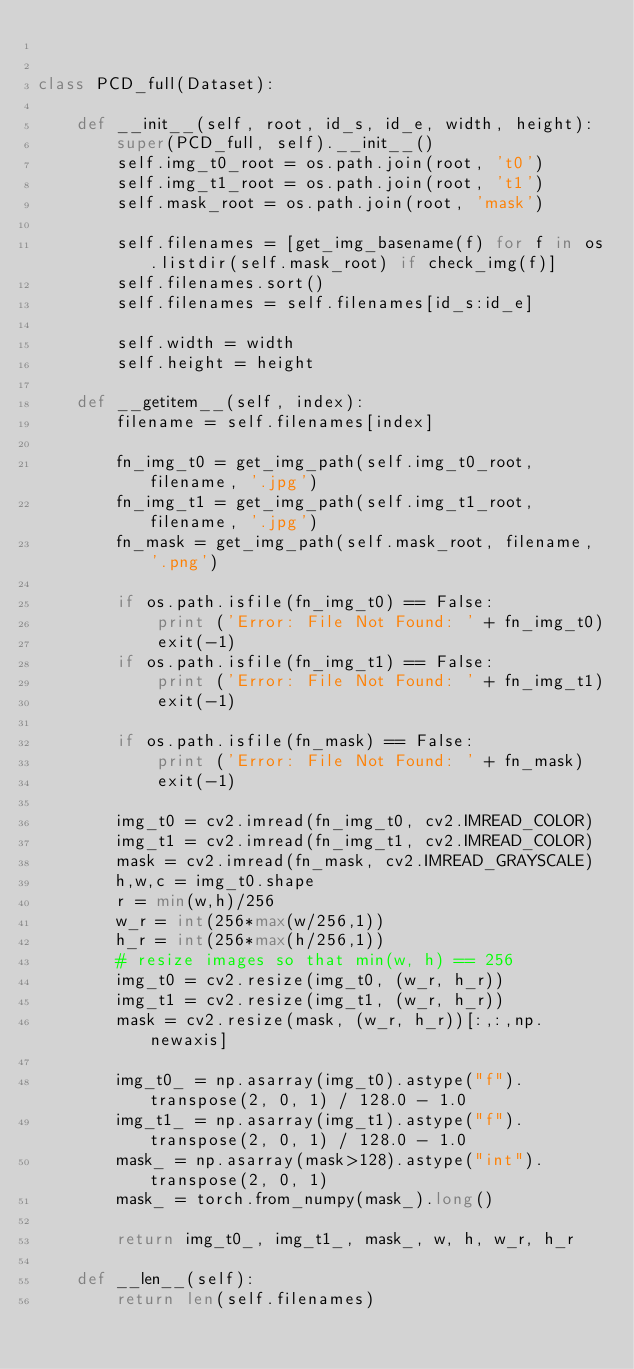Convert code to text. <code><loc_0><loc_0><loc_500><loc_500><_Python_>

class PCD_full(Dataset):

    def __init__(self, root, id_s, id_e, width, height):
        super(PCD_full, self).__init__()
        self.img_t0_root = os.path.join(root, 't0')
        self.img_t1_root = os.path.join(root, 't1')
        self.mask_root = os.path.join(root, 'mask')

        self.filenames = [get_img_basename(f) for f in os.listdir(self.mask_root) if check_img(f)]
        self.filenames.sort()
        self.filenames = self.filenames[id_s:id_e]

        self.width = width
        self.height = height

    def __getitem__(self, index):
        filename = self.filenames[index]

        fn_img_t0 = get_img_path(self.img_t0_root, filename, '.jpg')
        fn_img_t1 = get_img_path(self.img_t1_root, filename, '.jpg')
        fn_mask = get_img_path(self.mask_root, filename, '.png')

        if os.path.isfile(fn_img_t0) == False:
            print ('Error: File Not Found: ' + fn_img_t0)
            exit(-1)
        if os.path.isfile(fn_img_t1) == False:
            print ('Error: File Not Found: ' + fn_img_t1)
            exit(-1)

        if os.path.isfile(fn_mask) == False:
            print ('Error: File Not Found: ' + fn_mask)
            exit(-1)

        img_t0 = cv2.imread(fn_img_t0, cv2.IMREAD_COLOR)
        img_t1 = cv2.imread(fn_img_t1, cv2.IMREAD_COLOR)
        mask = cv2.imread(fn_mask, cv2.IMREAD_GRAYSCALE)
        h,w,c = img_t0.shape
        r = min(w,h)/256
        w_r = int(256*max(w/256,1))
        h_r = int(256*max(h/256,1))
        # resize images so that min(w, h) == 256
        img_t0 = cv2.resize(img_t0, (w_r, h_r))
        img_t1 = cv2.resize(img_t1, (w_r, h_r))
        mask = cv2.resize(mask, (w_r, h_r))[:,:,np.newaxis]

        img_t0_ = np.asarray(img_t0).astype("f").transpose(2, 0, 1) / 128.0 - 1.0
        img_t1_ = np.asarray(img_t1).astype("f").transpose(2, 0, 1) / 128.0 - 1.0
        mask_ = np.asarray(mask>128).astype("int").transpose(2, 0, 1)
        mask_ = torch.from_numpy(mask_).long()

        return img_t0_, img_t1_, mask_, w, h, w_r, h_r

    def __len__(self):
        return len(self.filenames)


</code> 